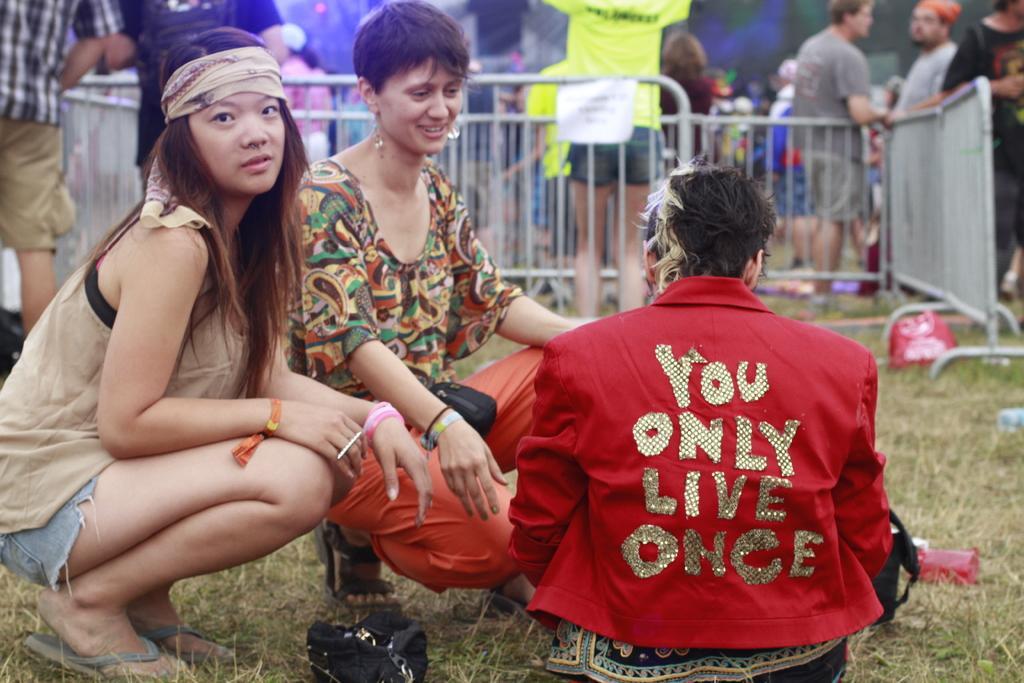Can you describe this image briefly? This picture seems to be clicked outside. On the left we can see the two persons squatting on the ground. On the right we can see a person wearing red color jacket and we can see the text on the jacket and the person is sitting on the ground and there are some objects lying on the ground and we can see the grass. In the center we can see the metal rods and group of persons seems to be standing and we can see the light and many other objects. 